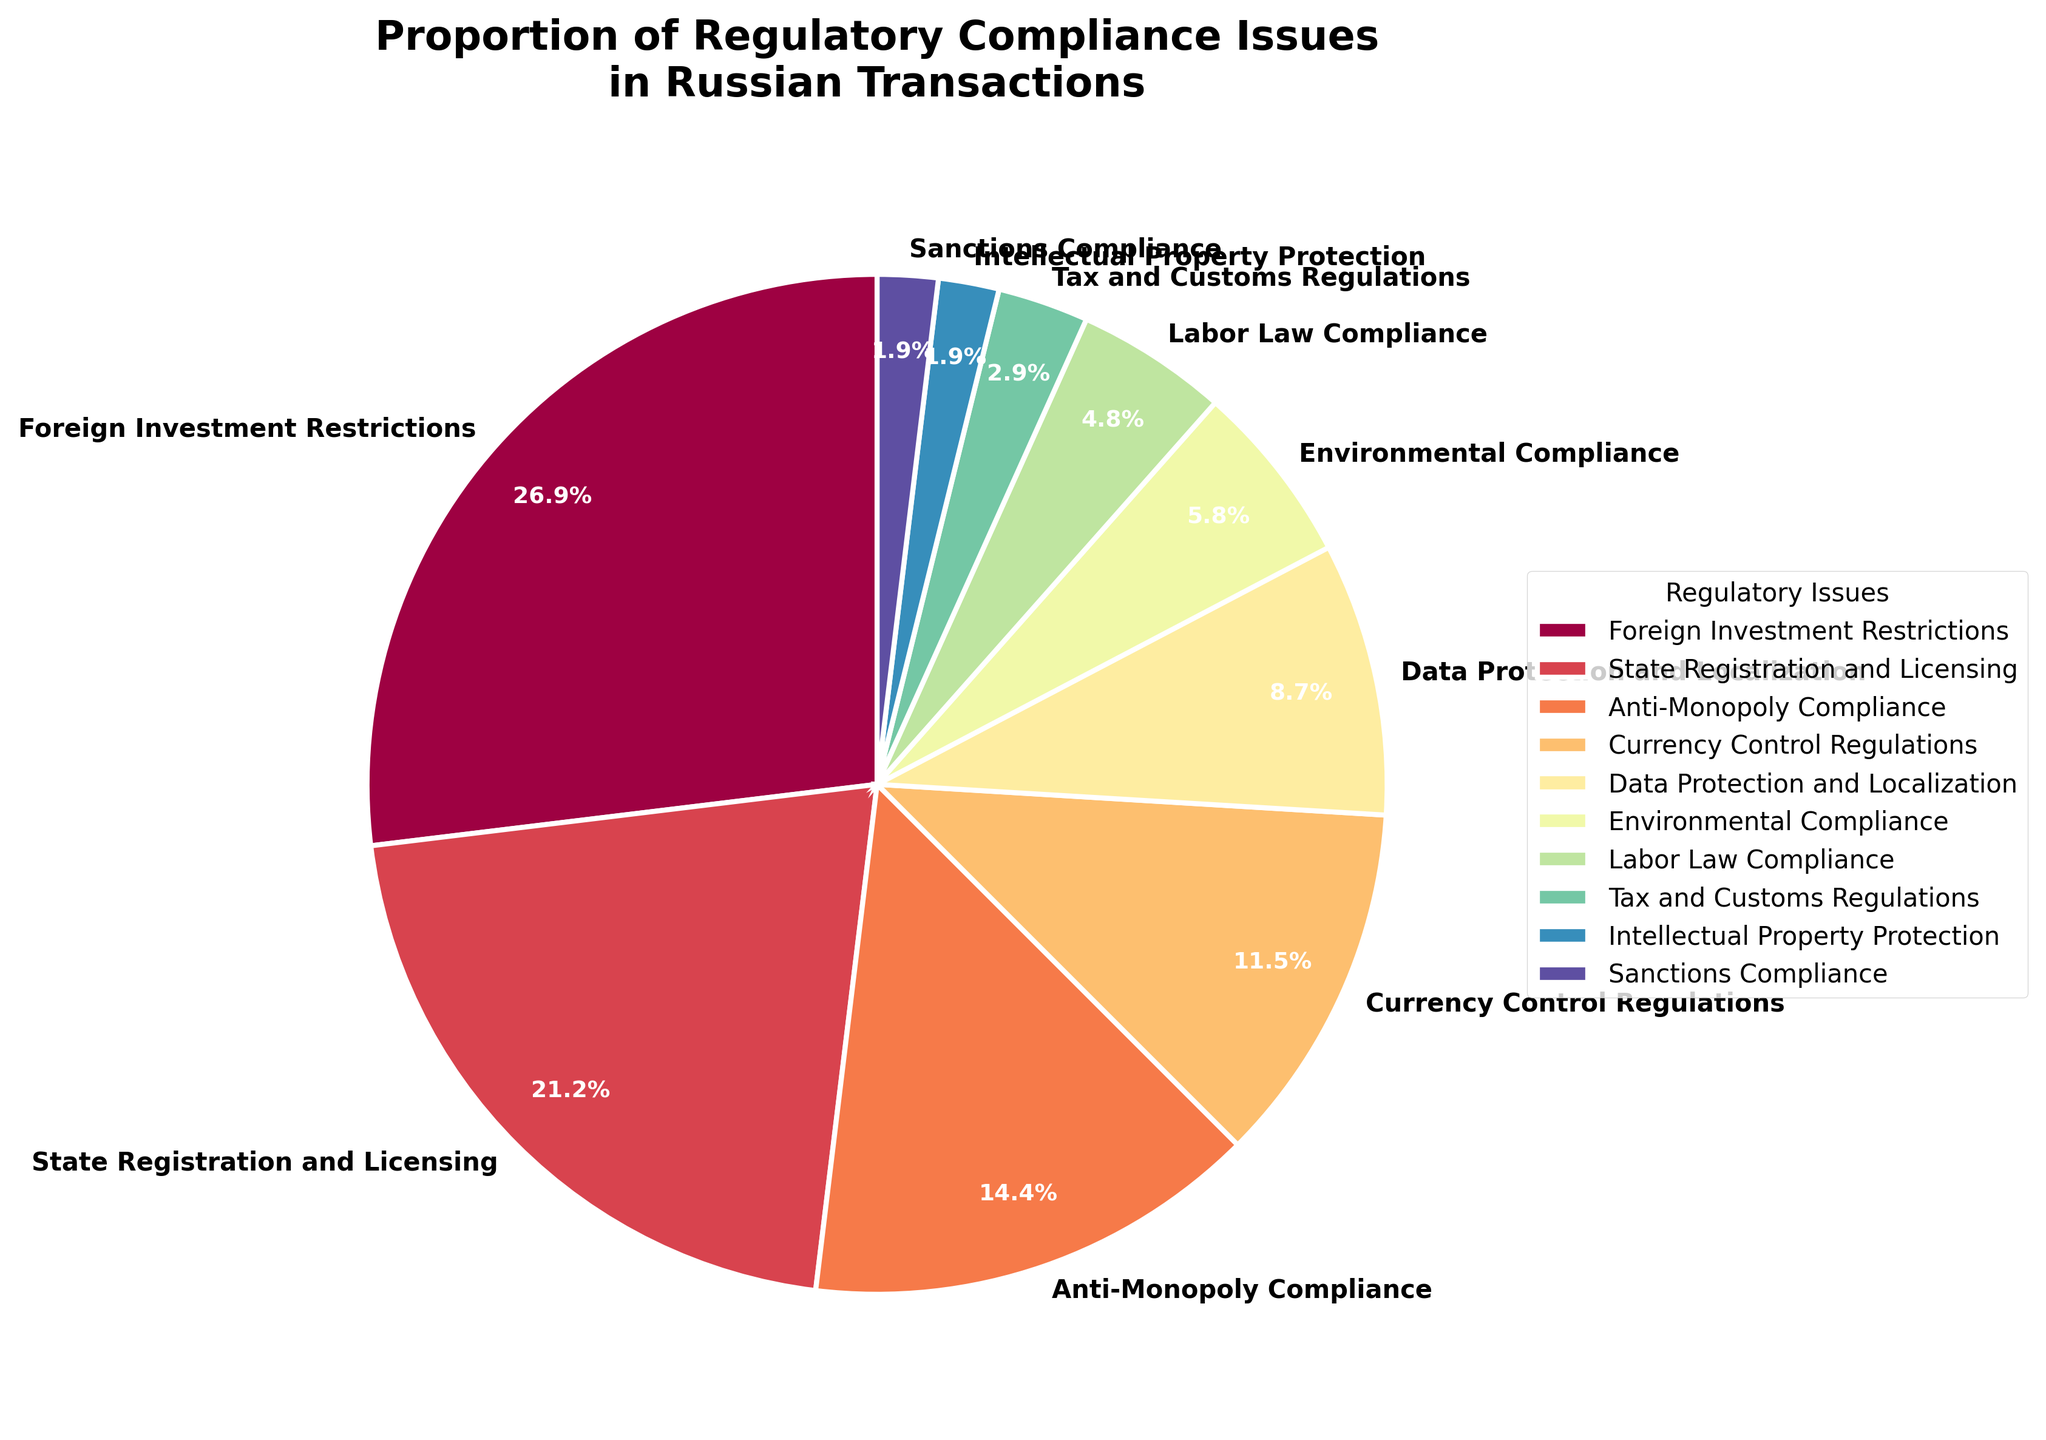Which regulatory issue has the largest proportion of compliance issues in Russian transactions? The figure shows that the section labeled "Foreign Investment Restrictions" occupies the largest portion of the pie chart.
Answer: Foreign Investment Restrictions What percentage of compliance issues is attributed to Data Protection and Localization? The pie chart segment labeled "Data Protection and Localization" shows the percentage within the segment.
Answer: 9% How much greater is the proportion of State Registration and Licensing issues compared to Labor Law Compliance? According to the pie chart, State Registration and Licensing has 22%, while Labor Law Compliance has 5%. The difference is 22% - 5% = 17%.
Answer: 17% What is the combined percentage of Anti-Monopoly Compliance and Environmental Compliance issues? From the pie chart: Anti-Monopoly Compliance is 15% and Environmental Compliance is 6%. Combined, it is 15% + 6% = 21%.
Answer: 21% Which regulatory issue has the smallest proportion of compliance issues, and what is its percentage? The pie chart shows that "Sanctions Compliance" and "Intellectual Property Protection" are both the smallest segments, each with a percentage indicated in the segment.
Answer: Sanctions Compliance, 2% Which group of regulatory issues represents more than half of the total compliance issues? Adding percentages based on the pie chart: Foreign Investment Restrictions (28%) + State Registration and Licensing (22%) + Anti-Monopoly Compliance (15%) = 65%. This group exceeds 50%.
Answer: Foreign Investment Restrictions, State Registration and Licensing, Anti-Monopoly Compliance How is the segment for Tax and Customs Regulations visually distinguished in the pie chart? By observing the pie chart, the segment is labeled "Tax and Customs Regulations" and is assigned a unique color distinct from other segments.
Answer: Unique color distinct from other segments Is the proportion of issues related to Foreign Investment Restrictions more than double those related to Data Protection and Localization? Foreign Investment Restrictions is 28% and Data Protection and Localization is 9%. Checking if 28% > 2 * 9% -> 28% > 18%, which is true.
Answer: Yes If you sum up the proportions of the three least prevalent issues, what is the total? From the pie chart: Sanctions Compliance (2%) + Intellectual Property Protection (2%) + Tax and Customs Regulations (3%). The total is 2% + 2% + 3% = 7%.
Answer: 7% Which regulatory issue’s segment is placed next to the segment for Environmental Compliance? By closely looking at the layout of the segments in the pie chart, one can identify the adjacent segment next to "Environmental Compliance".
Answer: Tax and Customs Regulations 